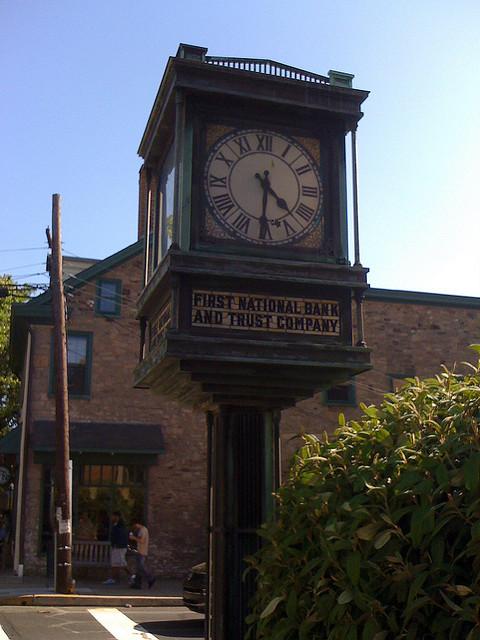Could the time be 8:00 PM?
Write a very short answer. No. Would it be appropriate for someone to change the name to First National Bank and Trust Company'?
Answer briefly. No. What season is depicted in this photo?
Write a very short answer. Summer. Does it appear to be rainy?
Short answer required. No. What time is on the clock?
Concise answer only. 4:30. 